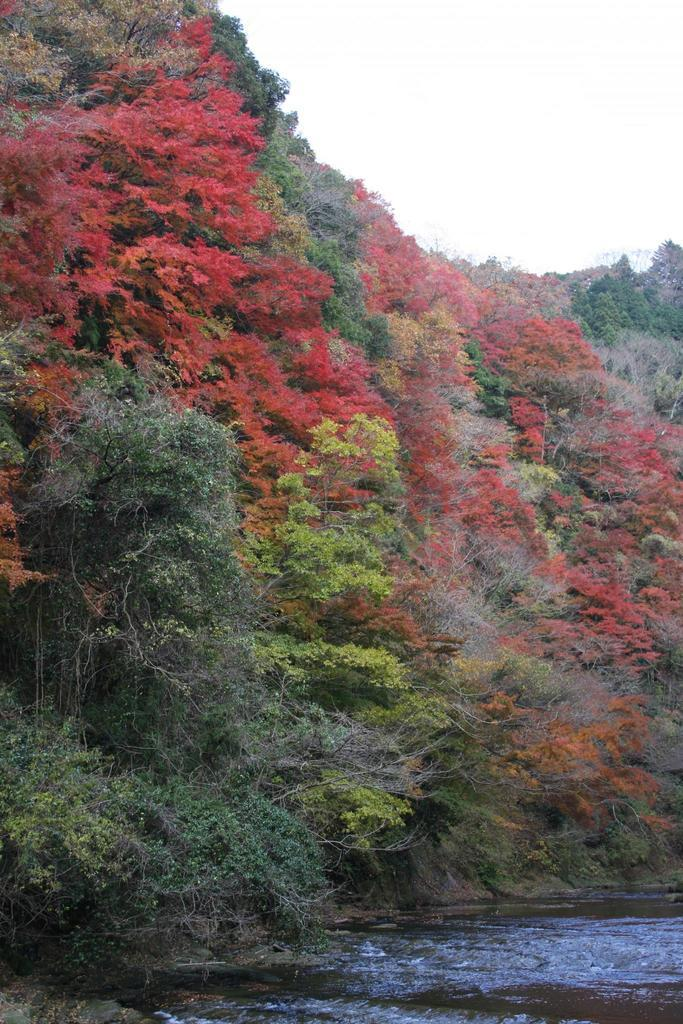What type of vegetation can be seen in the image? There are trees in the image. What body of water is present in the image? There is a river in the image. What part of the natural environment is visible in the image? The sky is visible in the image. What decision does the tramp make while standing near the river in the image? There is no tramp present in the image, so it is not possible to answer that question. 